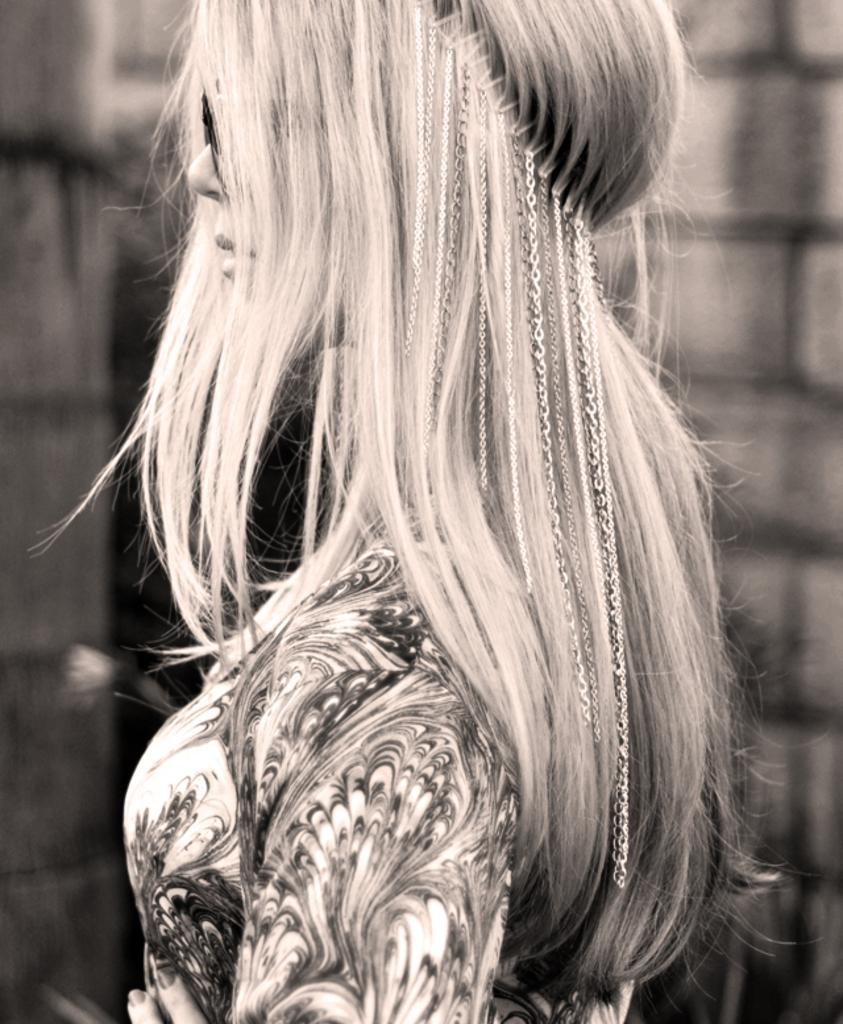What is the color scheme of the image? The image is black and white. Who is present in the image? There is a lady in the image. What accessory is the lady wearing? The lady is wearing glasses. What can be seen in the background of the image? There is a wall in the background of the image. What type of eggnog is being served in the image? There is no eggnog present in the image; it is a black and white image of a lady wearing glasses with a wall in the background. How many bubbles can be seen floating around the lady in the image? There are no bubbles present in the image. 